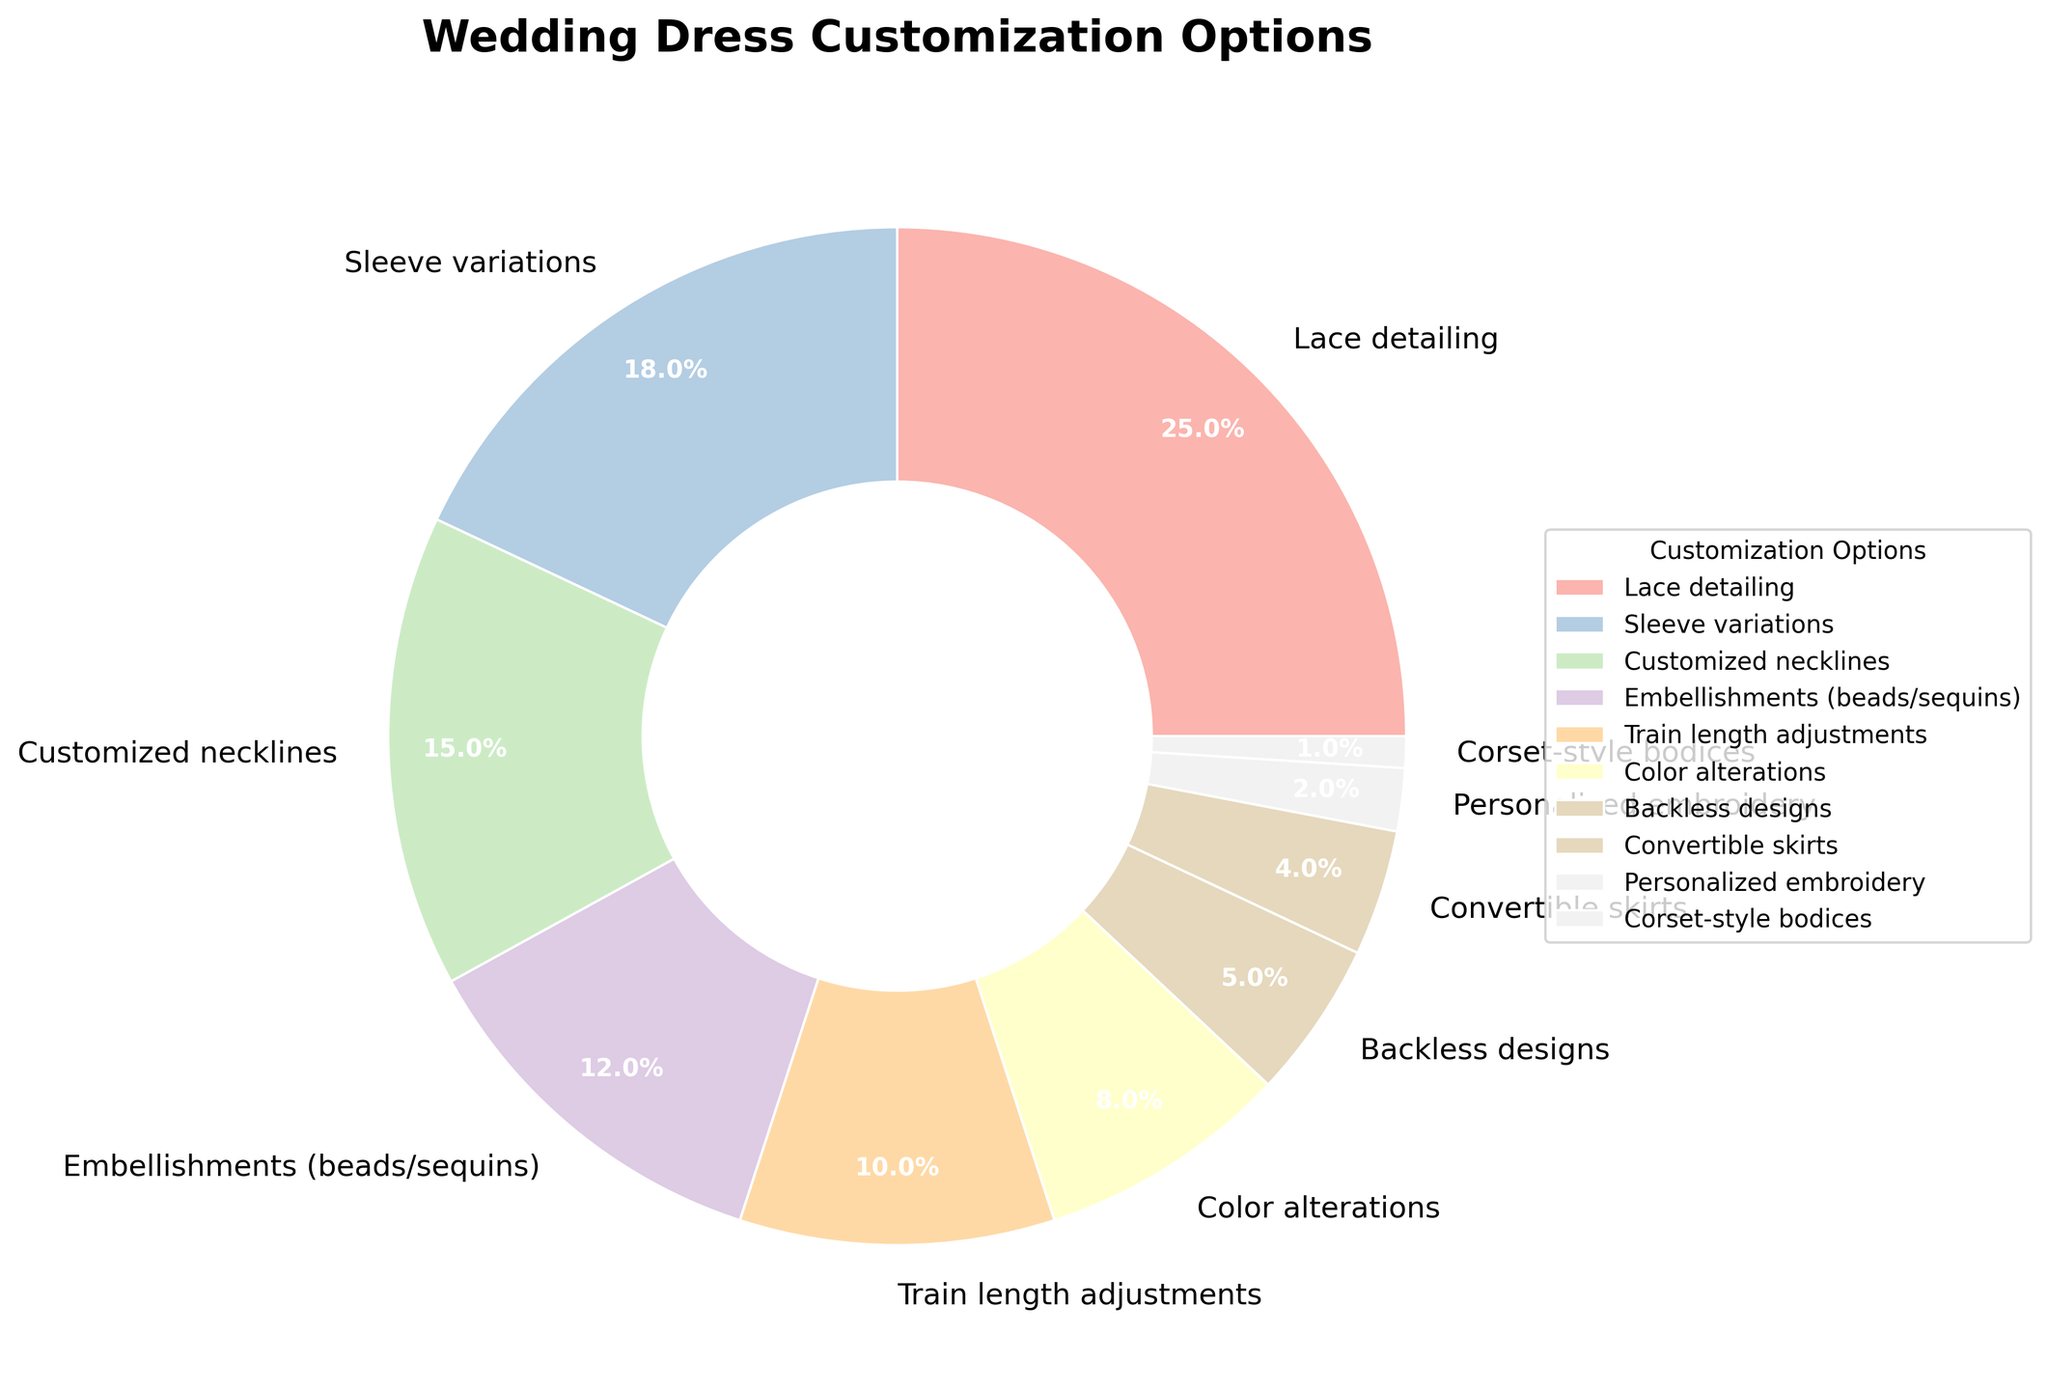What is the most popular wedding dress customization option? Lace detailing has the highest percentage, making it the most popular option according to the pie chart.
Answer: Lace detailing Which customization option has the lowest popularity? Corset-style bodices have the lowest percentage, thus the least popular customization option.
Answer: Corset-style bodices How much more popular is lace detailing compared to sleeve variations? Lace detailing is 25% while sleeve variations are 18%. The difference in popularity is 25% - 18% = 7%.
Answer: 7% What is the combined percentage of color alterations and backless designs? Color alterations have 8% and backless designs have 5%. Adding them together gives 8% + 5% = 13%.
Answer: 13% Are personalized embroidery and corset-style bodices together more popular than train length adjustments? Personalized embroidery is 2% and corset-style bodices are 1%. Together, they make 2% + 1% = 3%, which is less than the 10% of train length adjustments.
Answer: No Which customization options have a percentage between 10% and 20%? Sleeve variations (18%), customized necklines (15%), and embellishments like beads or sequins (12%) all fall within the 10%-20% range.
Answer: Sleeve variations, customized necklines, embellishments Is the popularity of train length adjustments more or less than half of lace detailing? Train length adjustments are 10%, and half of lace detailing, which is 25%, is 12.5%. 10% is less than 12.5%.
Answer: Less What is the total percentage of the three least popular customization options? The three least popular options are personalized embroidery (2%), corset-style bodices (1%), and convertible skirts (4%). The total percentage is 2% + 1% + 4% = 7%.
Answer: 7% Which is more popular, custom necklines or embellishments? Custom necklines have a 15% popularity while embellishments have 12%. Therefore, custom necklines are more popular.
Answer: Customized necklines 